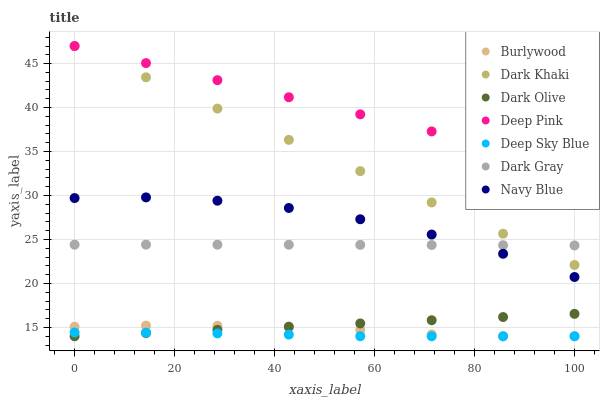Does Deep Sky Blue have the minimum area under the curve?
Answer yes or no. Yes. Does Deep Pink have the maximum area under the curve?
Answer yes or no. Yes. Does Burlywood have the minimum area under the curve?
Answer yes or no. No. Does Burlywood have the maximum area under the curve?
Answer yes or no. No. Is Deep Pink the smoothest?
Answer yes or no. Yes. Is Navy Blue the roughest?
Answer yes or no. Yes. Is Burlywood the smoothest?
Answer yes or no. No. Is Burlywood the roughest?
Answer yes or no. No. Does Burlywood have the lowest value?
Answer yes or no. Yes. Does Deep Pink have the lowest value?
Answer yes or no. No. Does Dark Khaki have the highest value?
Answer yes or no. Yes. Does Burlywood have the highest value?
Answer yes or no. No. Is Dark Olive less than Dark Khaki?
Answer yes or no. Yes. Is Dark Khaki greater than Deep Sky Blue?
Answer yes or no. Yes. Does Navy Blue intersect Dark Gray?
Answer yes or no. Yes. Is Navy Blue less than Dark Gray?
Answer yes or no. No. Is Navy Blue greater than Dark Gray?
Answer yes or no. No. Does Dark Olive intersect Dark Khaki?
Answer yes or no. No. 